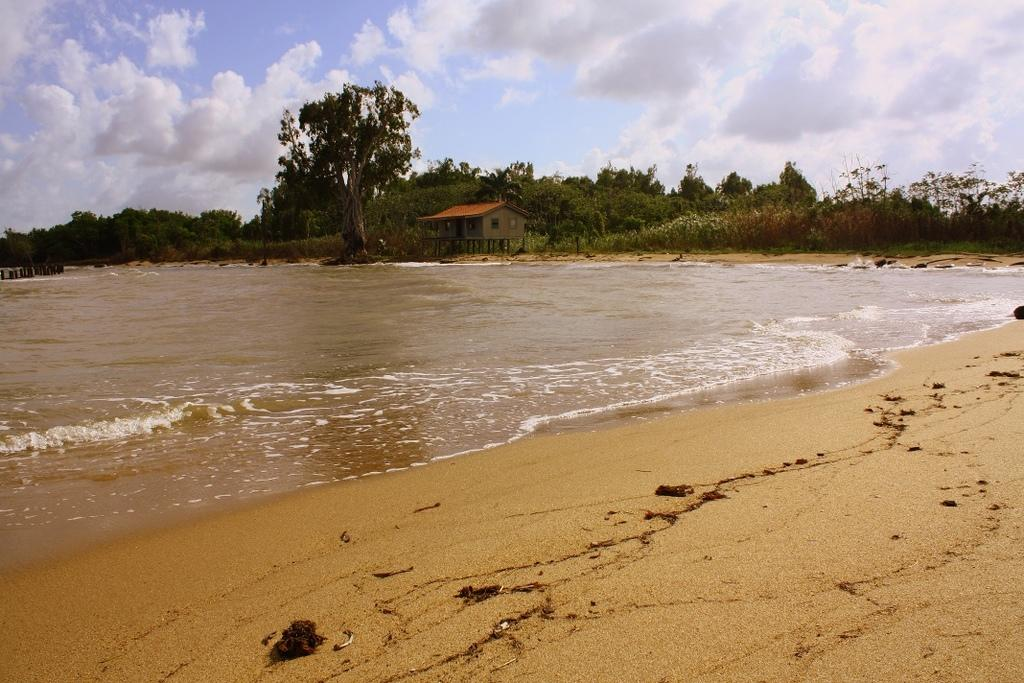What type of surface is visible in the image? There is a sand surface in the image. What can be seen in the distance behind the sand surface? There is a beach, a house, and trees in the background of the image. What color is the skin of the person playing with the ball in the image? There is no person or ball present in the image; it only features a sand surface and background elements. 